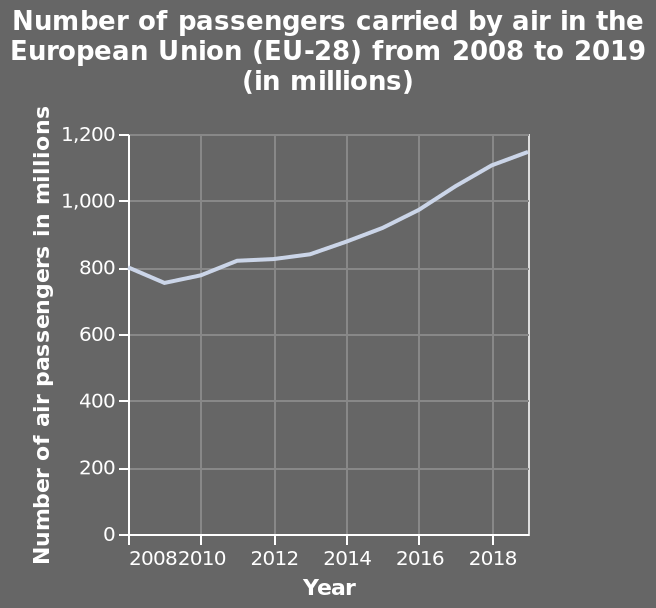<image>
What is the name of the line plot?  The line plot is named "Number of passengers carried by air in the European Union (EU-28) from 2008 to 2019 (in millions)." What is the range of years covered in the line plot? The line plot covers the years from 2008 to 2019. What is the number of passengers by 2019?  By 2019, the number of passengers had reached almost 1200 million. 